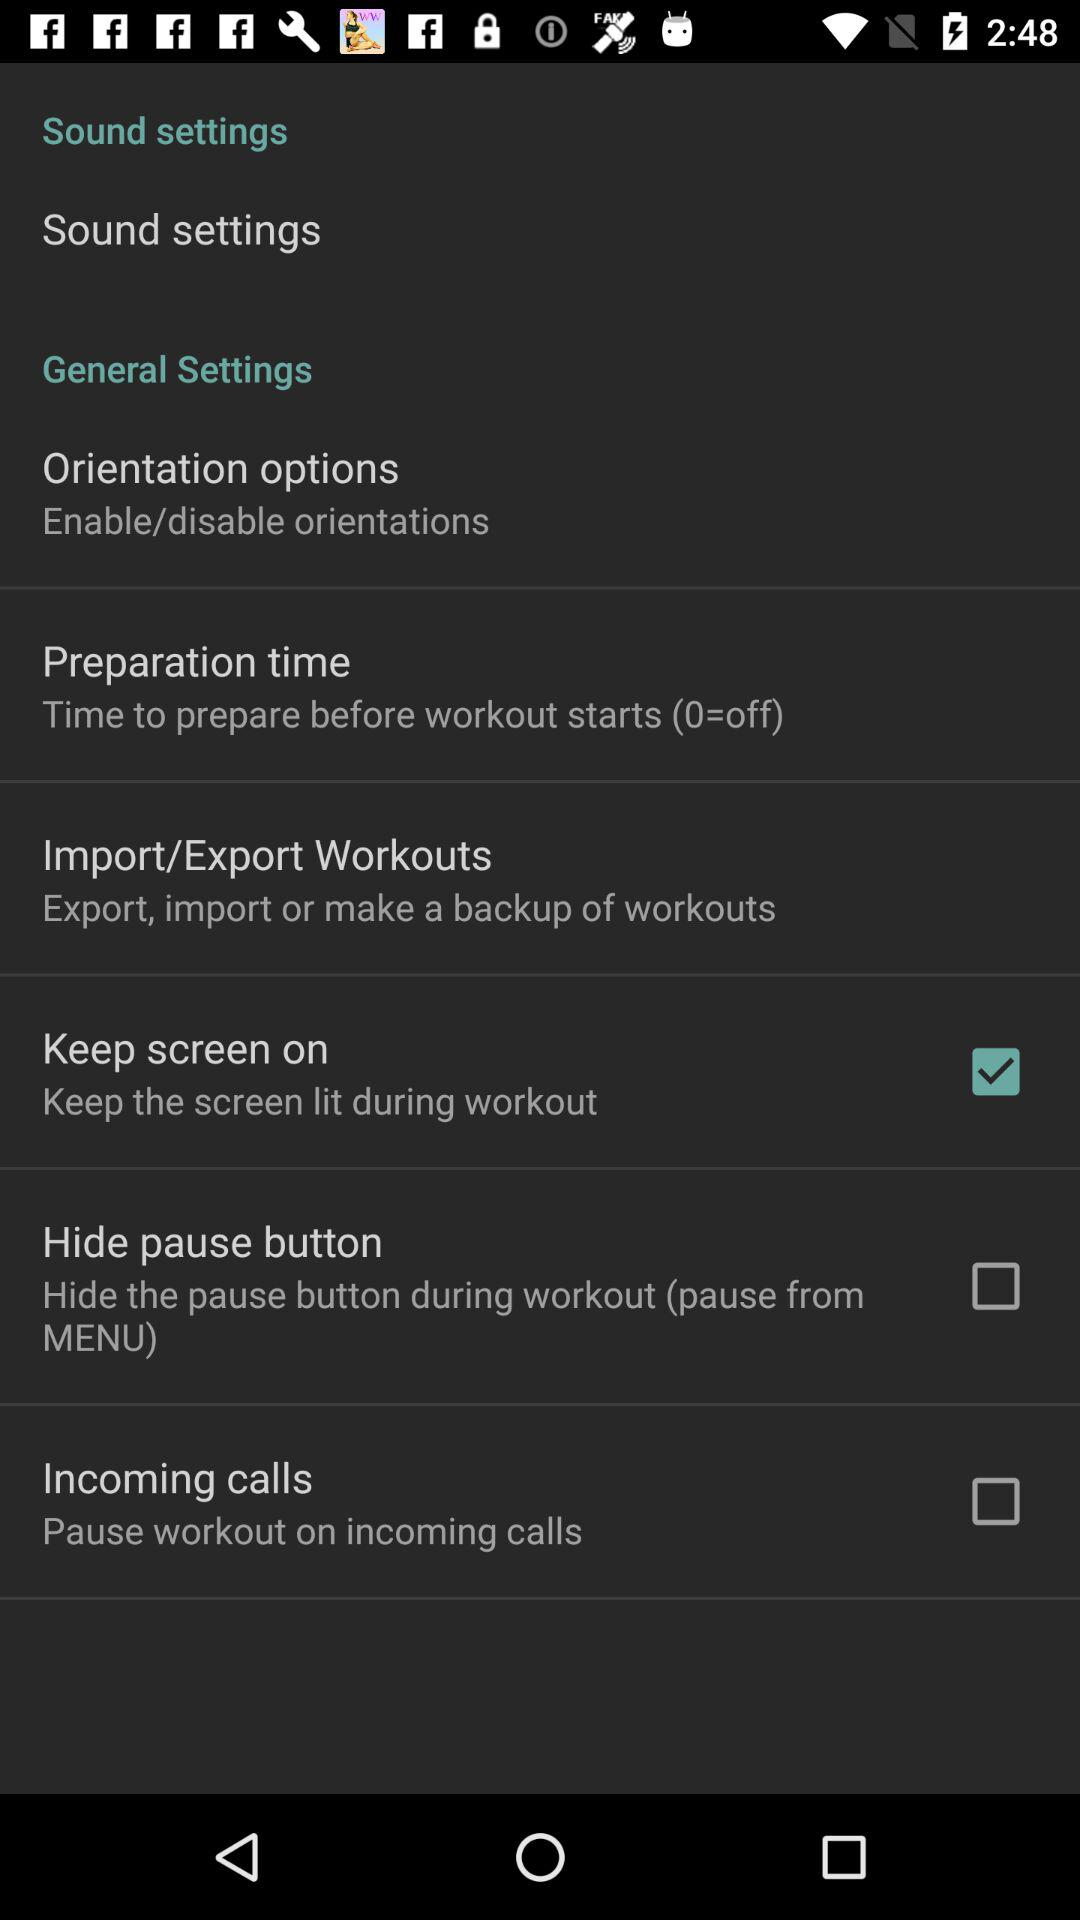What is the status of incoming calls? The status is off. 